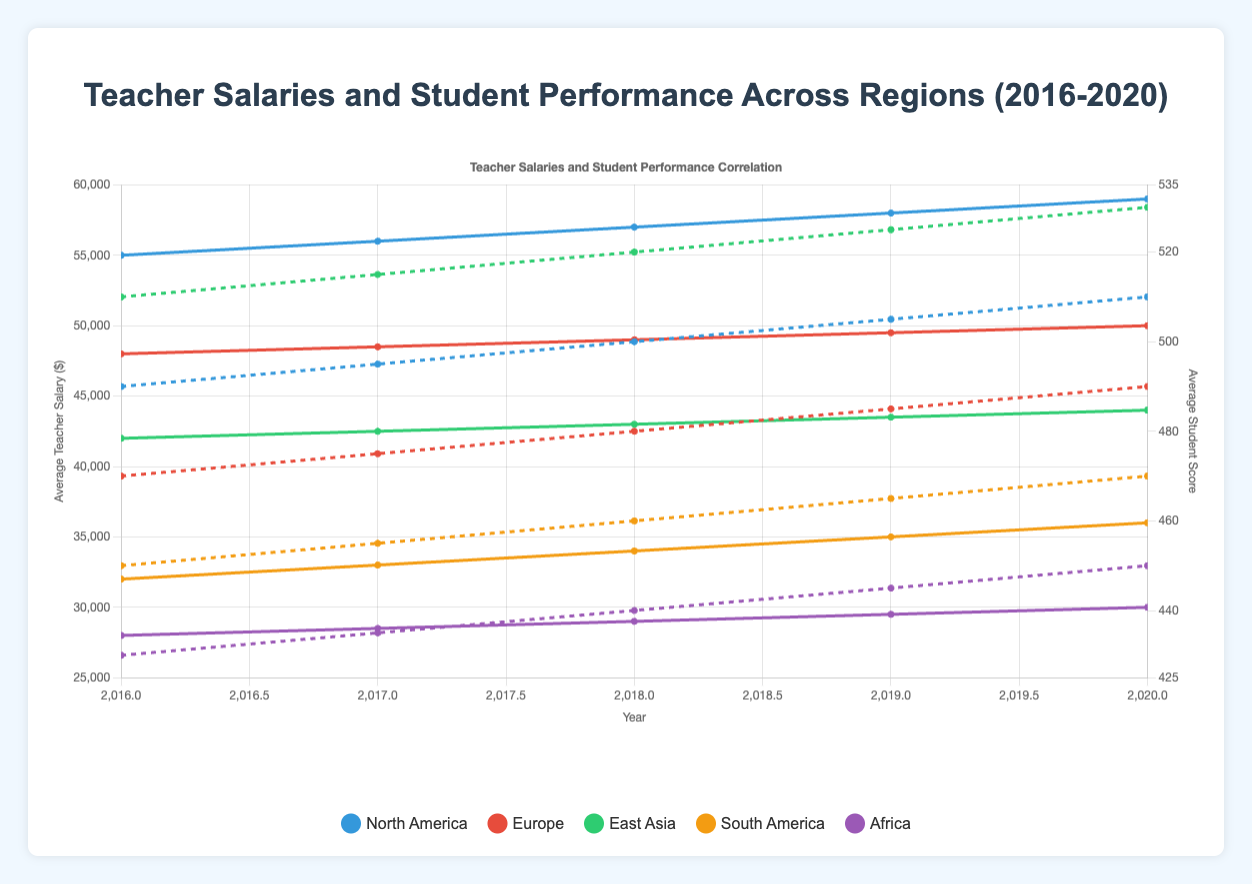What is the trend in average teacher salaries in North America from 2016 to 2020? From 2016 to 2020 in North America, average teacher salaries increased each year. The salaries were $55,000 in 2016, then rose to $56,000 in 2017, $57,000 in 2018, $58,000 in 2019, and finally reached $59,000 in 2020.
Answer: Increasing In which year did East Asia have the highest teacher salary and student score, respectively? The highest teacher salary in East Asia was $44,000, and the highest student score was 530, both occurring in the year 2020.
Answer: 2020 How do the average teacher salaries of North America in 2016 compare to Europe in 2020? In 2016, North America's average teacher salary was $55,000, while Europe's average teacher salary in 2020 was $50,000. Therefore, North America's average teacher salary was $5,000 higher than Europe's in 2020.
Answer: $5,000 higher What is the difference between the average student scores in Africa and East Asia in 2020? In 2020, the average student score in Africa was 450, while in East Asia it was 530. The difference between them is 530 - 450 = 80.
Answer: 80 Which region had the lowest average teacher salary in 2016 and what was it? In 2016, Africa had the lowest average teacher salary, which was $28,000.
Answer: Africa What is the combined increase in average teacher salary for Europe from 2016 to 2020? In 2016, the average teacher salary in Europe was $48,000. By 2020, it had increased to $50,000. The combined increase is $50,000 - $48,000 = $2,000.
Answer: $2,000 How much did the average student score in South America increase from 2016 to 2020? In 2016, the average student score in South America was 450. By 2020, it increased to 470. The rise in the score is 470 - 450 = 20.
Answer: 20 Which region shows the highest correlation between teacher salaries and student scores over the period of 2016 to 2020? Based on the visual trend, East Asia shows the highest correlation because both the average teacher salaries and the average student scores increase steadily each year.
Answer: East Asia 